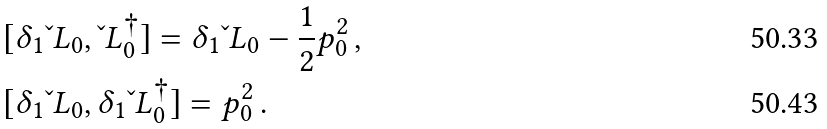Convert formula to latex. <formula><loc_0><loc_0><loc_500><loc_500>& [ \delta _ { 1 } \L L _ { 0 } , \L L _ { 0 } ^ { \dagger } ] = \delta _ { 1 } \L L _ { 0 } - \frac { 1 } { 2 } p _ { 0 } ^ { 2 } \, , \\ & [ \delta _ { 1 } \L L _ { 0 } , \delta _ { 1 } \L L _ { 0 } ^ { \dagger } ] = p _ { 0 } ^ { 2 } \, .</formula> 